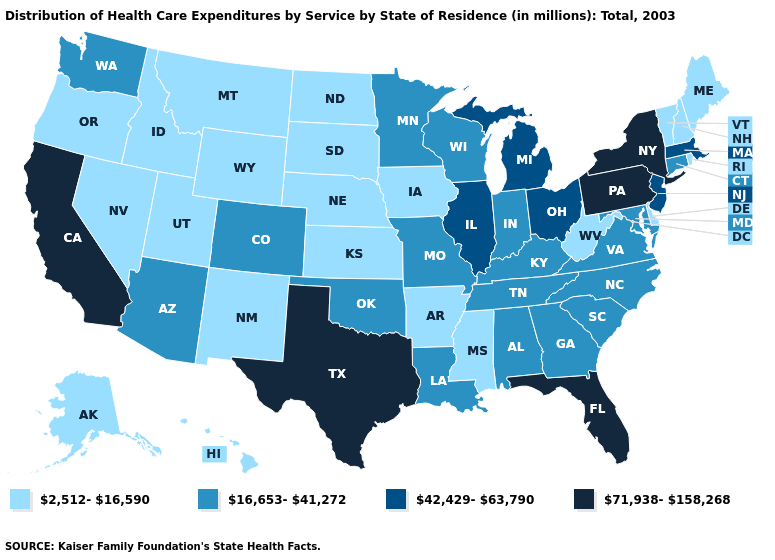What is the value of Wisconsin?
Short answer required. 16,653-41,272. What is the value of Pennsylvania?
Quick response, please. 71,938-158,268. Is the legend a continuous bar?
Keep it brief. No. Does Arkansas have a lower value than Alabama?
Write a very short answer. Yes. What is the highest value in the South ?
Keep it brief. 71,938-158,268. How many symbols are there in the legend?
Be succinct. 4. Does the first symbol in the legend represent the smallest category?
Quick response, please. Yes. Name the states that have a value in the range 16,653-41,272?
Keep it brief. Alabama, Arizona, Colorado, Connecticut, Georgia, Indiana, Kentucky, Louisiana, Maryland, Minnesota, Missouri, North Carolina, Oklahoma, South Carolina, Tennessee, Virginia, Washington, Wisconsin. Does the map have missing data?
Concise answer only. No. Does North Carolina have a lower value than South Carolina?
Be succinct. No. What is the highest value in the MidWest ?
Write a very short answer. 42,429-63,790. Is the legend a continuous bar?
Quick response, please. No. Which states hav the highest value in the MidWest?
Short answer required. Illinois, Michigan, Ohio. Among the states that border Arkansas , which have the lowest value?
Write a very short answer. Mississippi. What is the highest value in states that border Maryland?
Concise answer only. 71,938-158,268. 